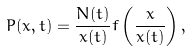<formula> <loc_0><loc_0><loc_500><loc_500>P ( x , t ) = \frac { N ( t ) } { \bar { x } ( t ) } f \left ( \frac { x } { \bar { x } ( t ) } \right ) ,</formula> 